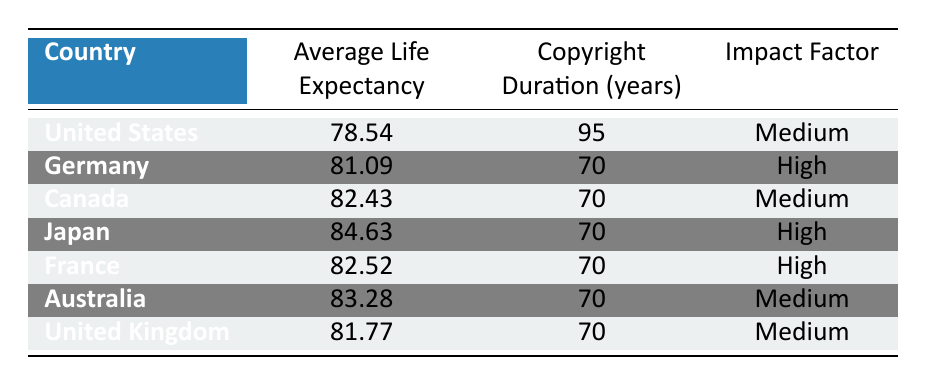What is the copyright duration for the United States? The table lists the copyright duration for the United States as 95 years.
Answer: 95 Which country has the highest average life expectancy? The maximum average life expectancy listed in the table is 84.63 years for Japan.
Answer: Japan What is the average life expectancy of Germany? The table indicates that the average life expectancy for Germany is 81.09 years.
Answer: 81.09 How many countries have a medium impact factor? Referring to the impact factor column, the countries with a medium impact factor are the United States, Canada, Australia, and the United Kingdom, totaling four.
Answer: 4 What is the difference in copyright duration between the United States and Canada? The copyright duration for the United States is 95 years and for Canada is 70 years. The difference is 95 - 70 = 25 years.
Answer: 25 Is it true that Japan has a higher copyright duration than Germany? Japan's copyright duration is 70 years, while Germany's is also 70 years, so it is false that Japan has a higher duration.
Answer: No What is the average life expectancy for countries with a high impact factor? The countries with a high impact factor are Germany, Japan, and France, with average life expectancies of 81.09, 84.63, and 82.52 years respectively. The average is calculated as (81.09 + 84.63 + 82.52) / 3 = 82.41 years.
Answer: 82.41 How does the copyright duration of countries with an average life expectancy over 80 compare to the United States? The countries with an average life expectancy over 80 are Germany, Japan, Canada, France, and Australia. Their respective copyright durations are 70 years, all of which are shorter than the United States' duration of 95 years.
Answer: Shorter Which countries have the same copyright duration? Germany, Canada, Japan, France, Australia, and the United Kingdom all have a copyright duration of 70 years.
Answer: 6 